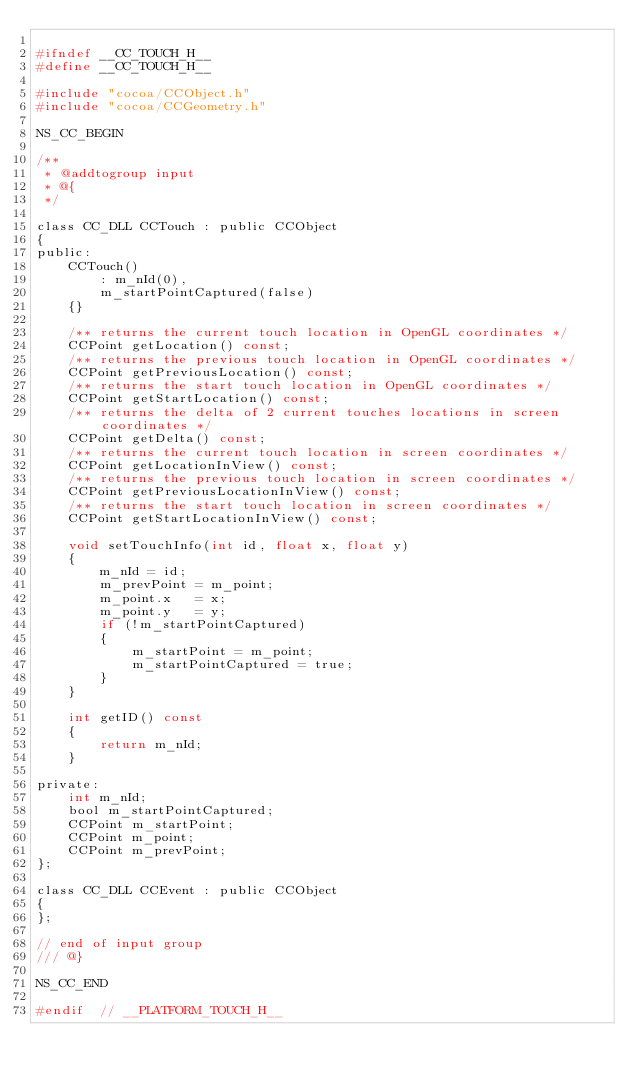Convert code to text. <code><loc_0><loc_0><loc_500><loc_500><_C_>
#ifndef __CC_TOUCH_H__
#define __CC_TOUCH_H__

#include "cocoa/CCObject.h"
#include "cocoa/CCGeometry.h"

NS_CC_BEGIN

/**
 * @addtogroup input
 * @{
 */

class CC_DLL CCTouch : public CCObject
{
public:
    CCTouch() 
        : m_nId(0),
        m_startPointCaptured(false)
    {}

    /** returns the current touch location in OpenGL coordinates */
    CCPoint getLocation() const;
    /** returns the previous touch location in OpenGL coordinates */
    CCPoint getPreviousLocation() const;
    /** returns the start touch location in OpenGL coordinates */
    CCPoint getStartLocation() const;
    /** returns the delta of 2 current touches locations in screen coordinates */
    CCPoint getDelta() const;
    /** returns the current touch location in screen coordinates */
    CCPoint getLocationInView() const;
    /** returns the previous touch location in screen coordinates */
    CCPoint getPreviousLocationInView() const;
    /** returns the start touch location in screen coordinates */
    CCPoint getStartLocationInView() const;
    
    void setTouchInfo(int id, float x, float y)
    {
        m_nId = id;
        m_prevPoint = m_point;
        m_point.x   = x;
        m_point.y   = y;
        if (!m_startPointCaptured)
        {
            m_startPoint = m_point;
            m_startPointCaptured = true;
        }
    }

    int getID() const
    {
        return m_nId;
    }

private:
    int m_nId;
    bool m_startPointCaptured;
    CCPoint m_startPoint;
    CCPoint m_point;
    CCPoint m_prevPoint;
};

class CC_DLL CCEvent : public CCObject
{
};

// end of input group
/// @}

NS_CC_END

#endif  // __PLATFORM_TOUCH_H__
</code> 